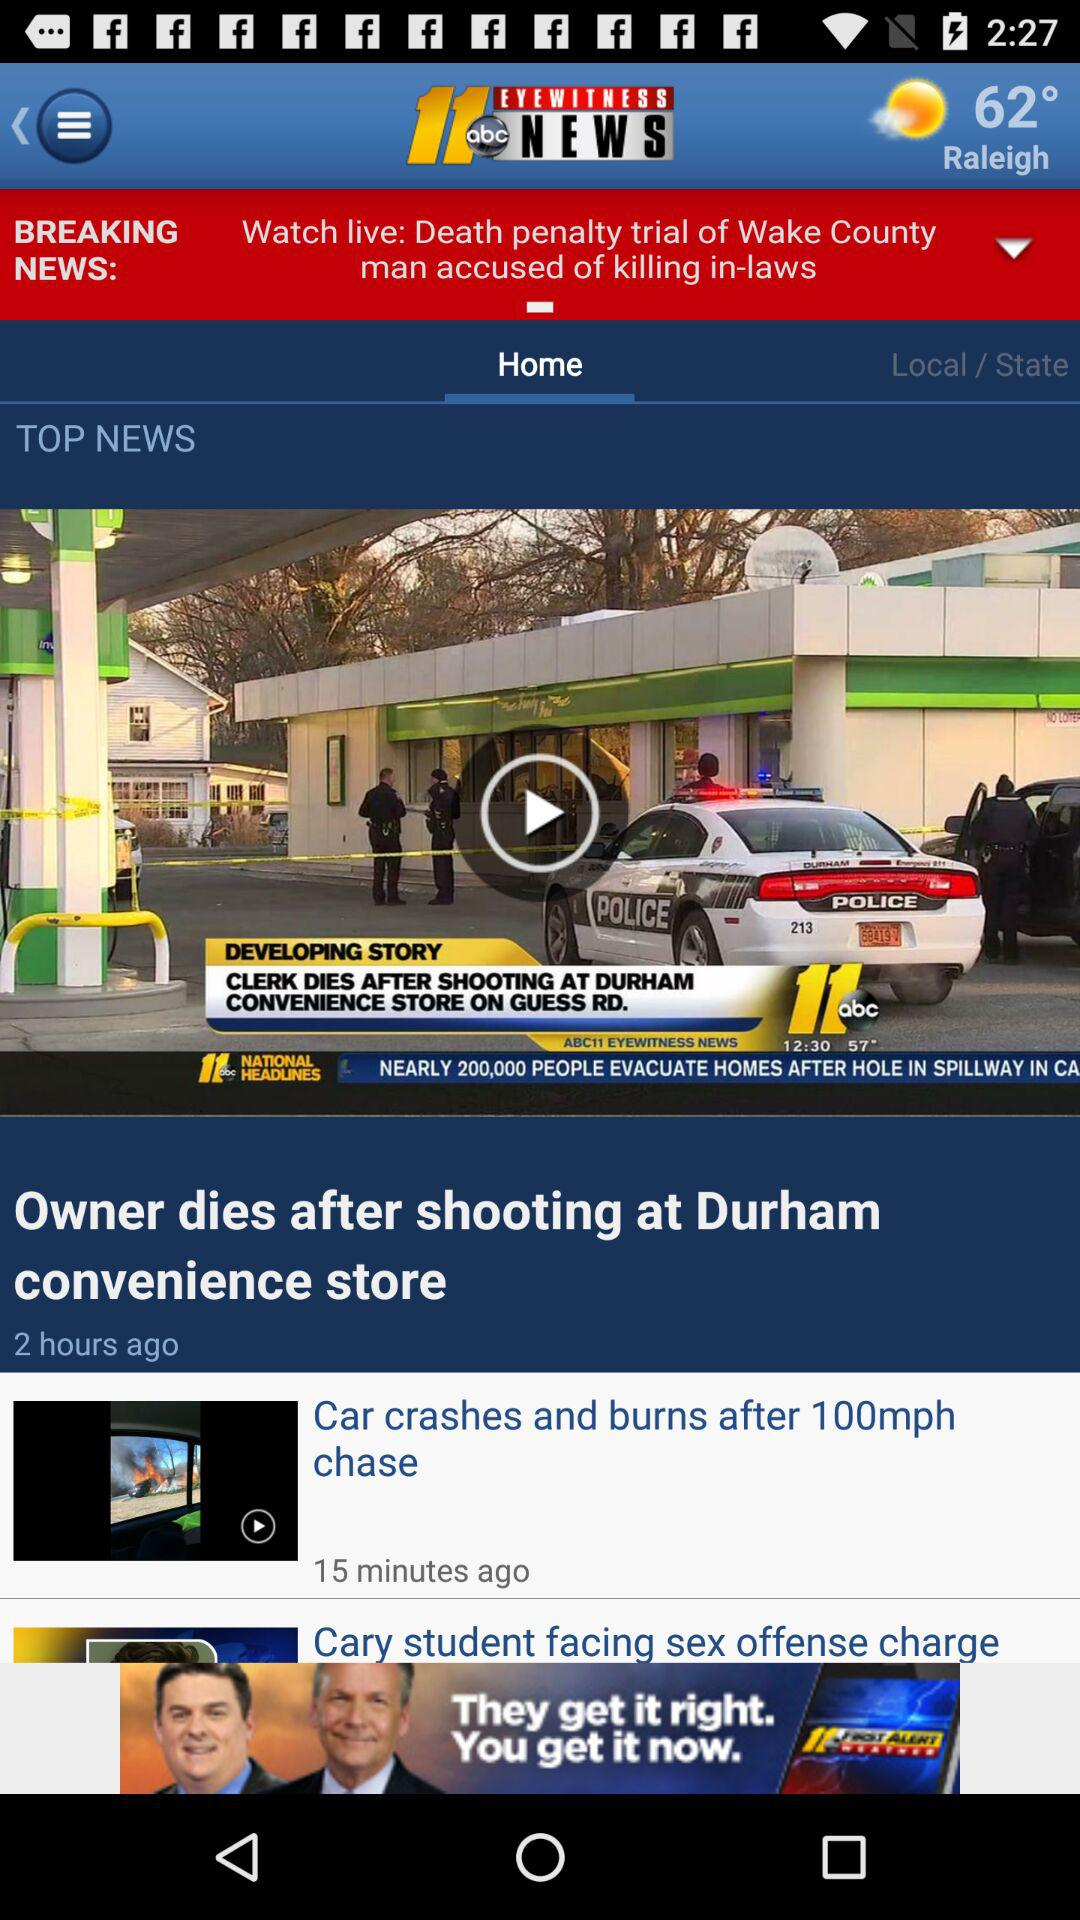What is the name of the application? The name of the application is "ABC11 North Carolina". 